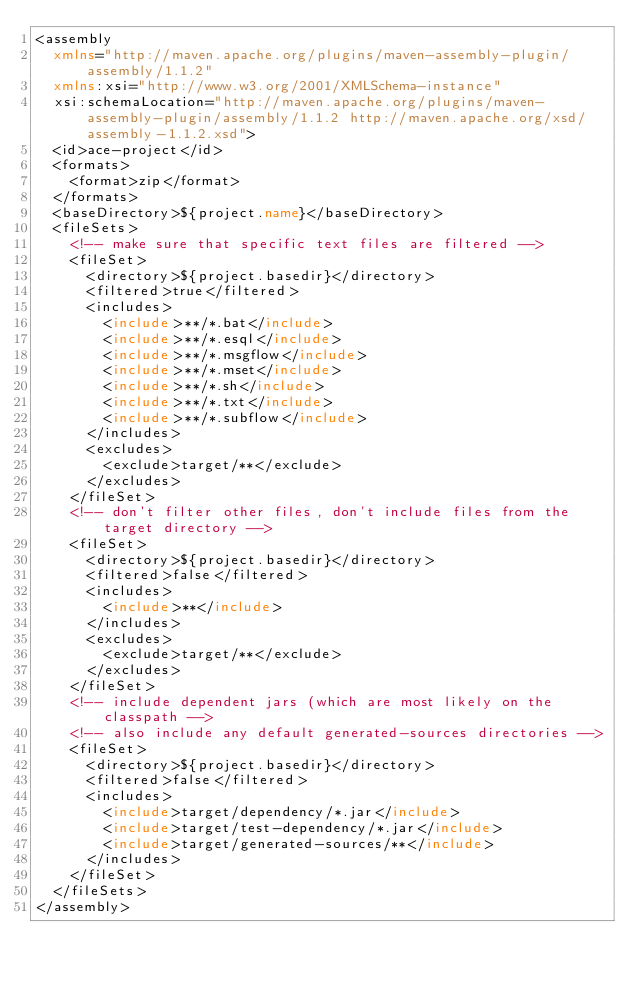Convert code to text. <code><loc_0><loc_0><loc_500><loc_500><_XML_><assembly
	xmlns="http://maven.apache.org/plugins/maven-assembly-plugin/assembly/1.1.2"
	xmlns:xsi="http://www.w3.org/2001/XMLSchema-instance"
	xsi:schemaLocation="http://maven.apache.org/plugins/maven-assembly-plugin/assembly/1.1.2 http://maven.apache.org/xsd/assembly-1.1.2.xsd">
	<id>ace-project</id>
	<formats>
		<format>zip</format>
	</formats>
	<baseDirectory>${project.name}</baseDirectory>
	<fileSets>
		<!-- make sure that specific text files are filtered -->
		<fileSet>
			<directory>${project.basedir}</directory>
			<filtered>true</filtered>
			<includes>
				<include>**/*.bat</include>
				<include>**/*.esql</include>
				<include>**/*.msgflow</include>
				<include>**/*.mset</include>
				<include>**/*.sh</include>
				<include>**/*.txt</include>
				<include>**/*.subflow</include>
			</includes>
			<excludes>
				<exclude>target/**</exclude>
			</excludes>
		</fileSet>
		<!-- don't filter other files, don't include files from the target directory -->
		<fileSet>
			<directory>${project.basedir}</directory>
			<filtered>false</filtered>
			<includes>
				<include>**</include>
			</includes>
			<excludes>
				<exclude>target/**</exclude>
			</excludes>
		</fileSet>
		<!-- include dependent jars (which are most likely on the classpath -->
		<!-- also include any default generated-sources directories -->
		<fileSet>
			<directory>${project.basedir}</directory>
			<filtered>false</filtered>
			<includes>
				<include>target/dependency/*.jar</include>
				<include>target/test-dependency/*.jar</include>
				<include>target/generated-sources/**</include>
			</includes>
		</fileSet>
	</fileSets>
</assembly></code> 